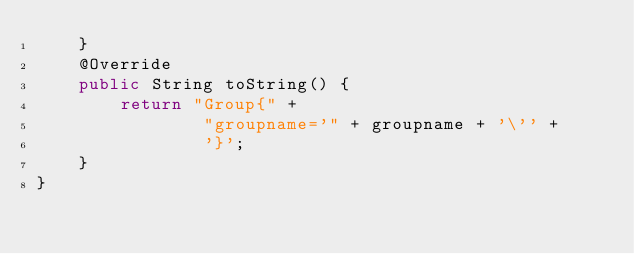Convert code to text. <code><loc_0><loc_0><loc_500><loc_500><_Java_>    }
    @Override
    public String toString() {
        return "Group{" +
                "groupname='" + groupname + '\'' +
                '}';
    }
}
</code> 